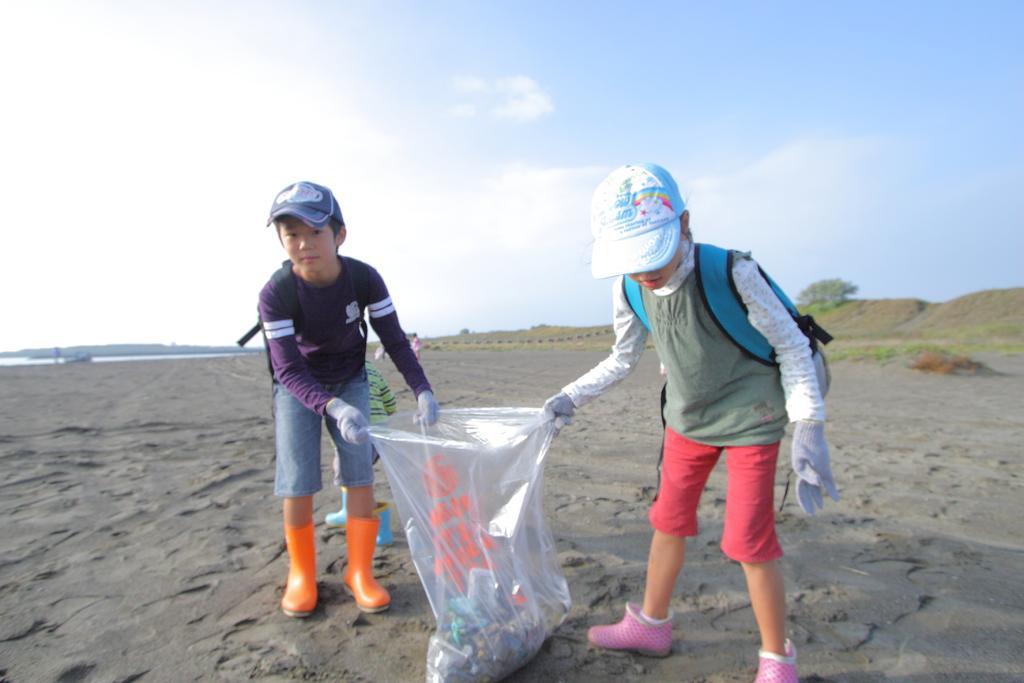How would you summarize this image in a sentence or two? In this picture we can see two kids, they wore caps, and they are holding a bag, in the background we can find few more people, trees and water. 